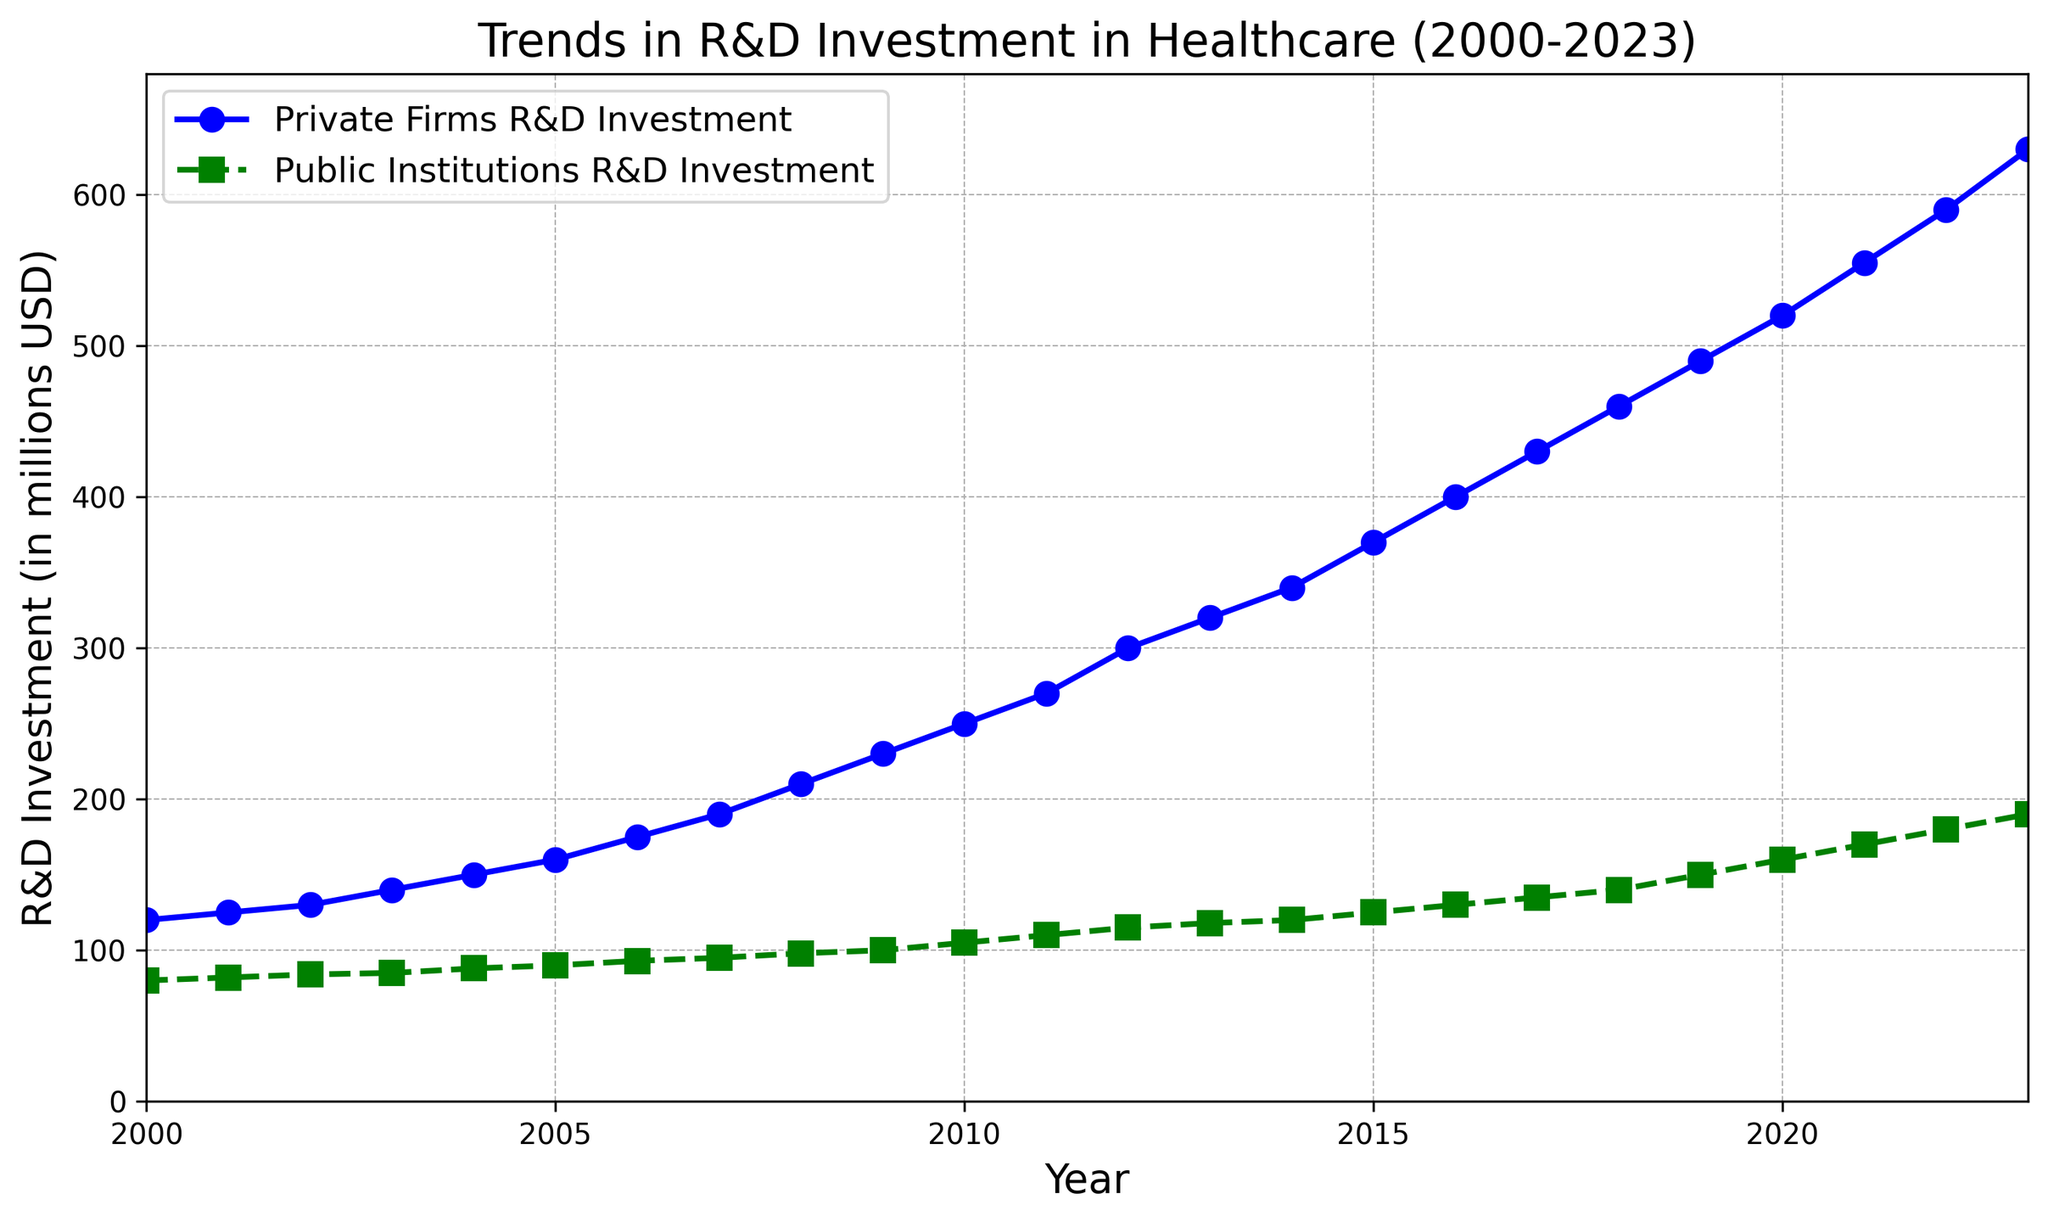What's the jump in Private Firms' R&D Investment between 2000 and 2023? To find the jump, subtract the R&D value of Private Firms in 2000 from the value in 2023. That is 630 (value in 2023) minus 120 (value in 2000).
Answer: 510 How much more did Private Firms invest in R&D compared to Public Institutions in the year 2010? Subtract the R&D investment of Public Institutions from that of Private Firms for the year 2010. That is 250 (Private Firms) minus 105 (Public Institutions).
Answer: 145 What's the average R&D investment of Public Institutions over the years 2000-2023? Sum up all the R&D investments of Public Institutions from 2000-2023 and divide by the number of years (24 years). The sum is 2856, so the average is 2856/24.
Answer: 119 During which year did Private Firms' R&D investment surpass 200 million USD for the first time? Look at the figure to find the first year when the Private Firms' R&D investment crosses above the 200 million USD mark. This happened in 2008 with an investment of 210 million USD.
Answer: 2008 In which year did Public Institutions see the greatest single-year increase in R&D investment? Compare the differences between consecutive years for Public Institutions' R&D investment, and find the year with the highest increase. The largest increase occurs between 2022 and 2023, an increase of 10 million USD.
Answer: 2023 By how much has Public Institutions' R&D investment increased from 2000 to 2023? Subtract the R&D investment in 2000 from that in 2023 for Public Institutions. That is 190 (value in 2023) minus 80 (value in 2000).
Answer: 110 Which sector showed a more consistent annual increase in R&D investment—Private Firms or Public Institutions? Assess the general trend and stability of the annual increase visually. Public Institutions showed a more consistent increase with a steadier line compared to Private Firms which had steeper increases in later years.
Answer: Public Institutions What’s the difference in R&D investment between the two sectors in 2017? Subtract the R&D investment of Public Institutions from that of Private Firms for the year 2017. That is 430 (Private Firms) minus 135 (Public Institutions).
Answer: 295 Which year had a larger increase in R&D investment for Private Firms, 2009 or 2012? Compare the increases between 2008 and 2009 and between 2011 and 2012 for Private Firms. From 2008 to 2009, the increase is 230 - 210 = 20 million USD. From 2011 to 2012, the increase is 300 - 270 = 30 million USD.
Answer: 2012 What's the average difference in R&D investment between Private Firms and Public Institutions over the period 2000-2023? Calculate the yearly differences between Private Firms and Public Institutions' R&D investments, sum those differences, and divide by the number of years (24 years). The sum of the differences is 4845, so the average difference is 4845/24.
Answer: 202 